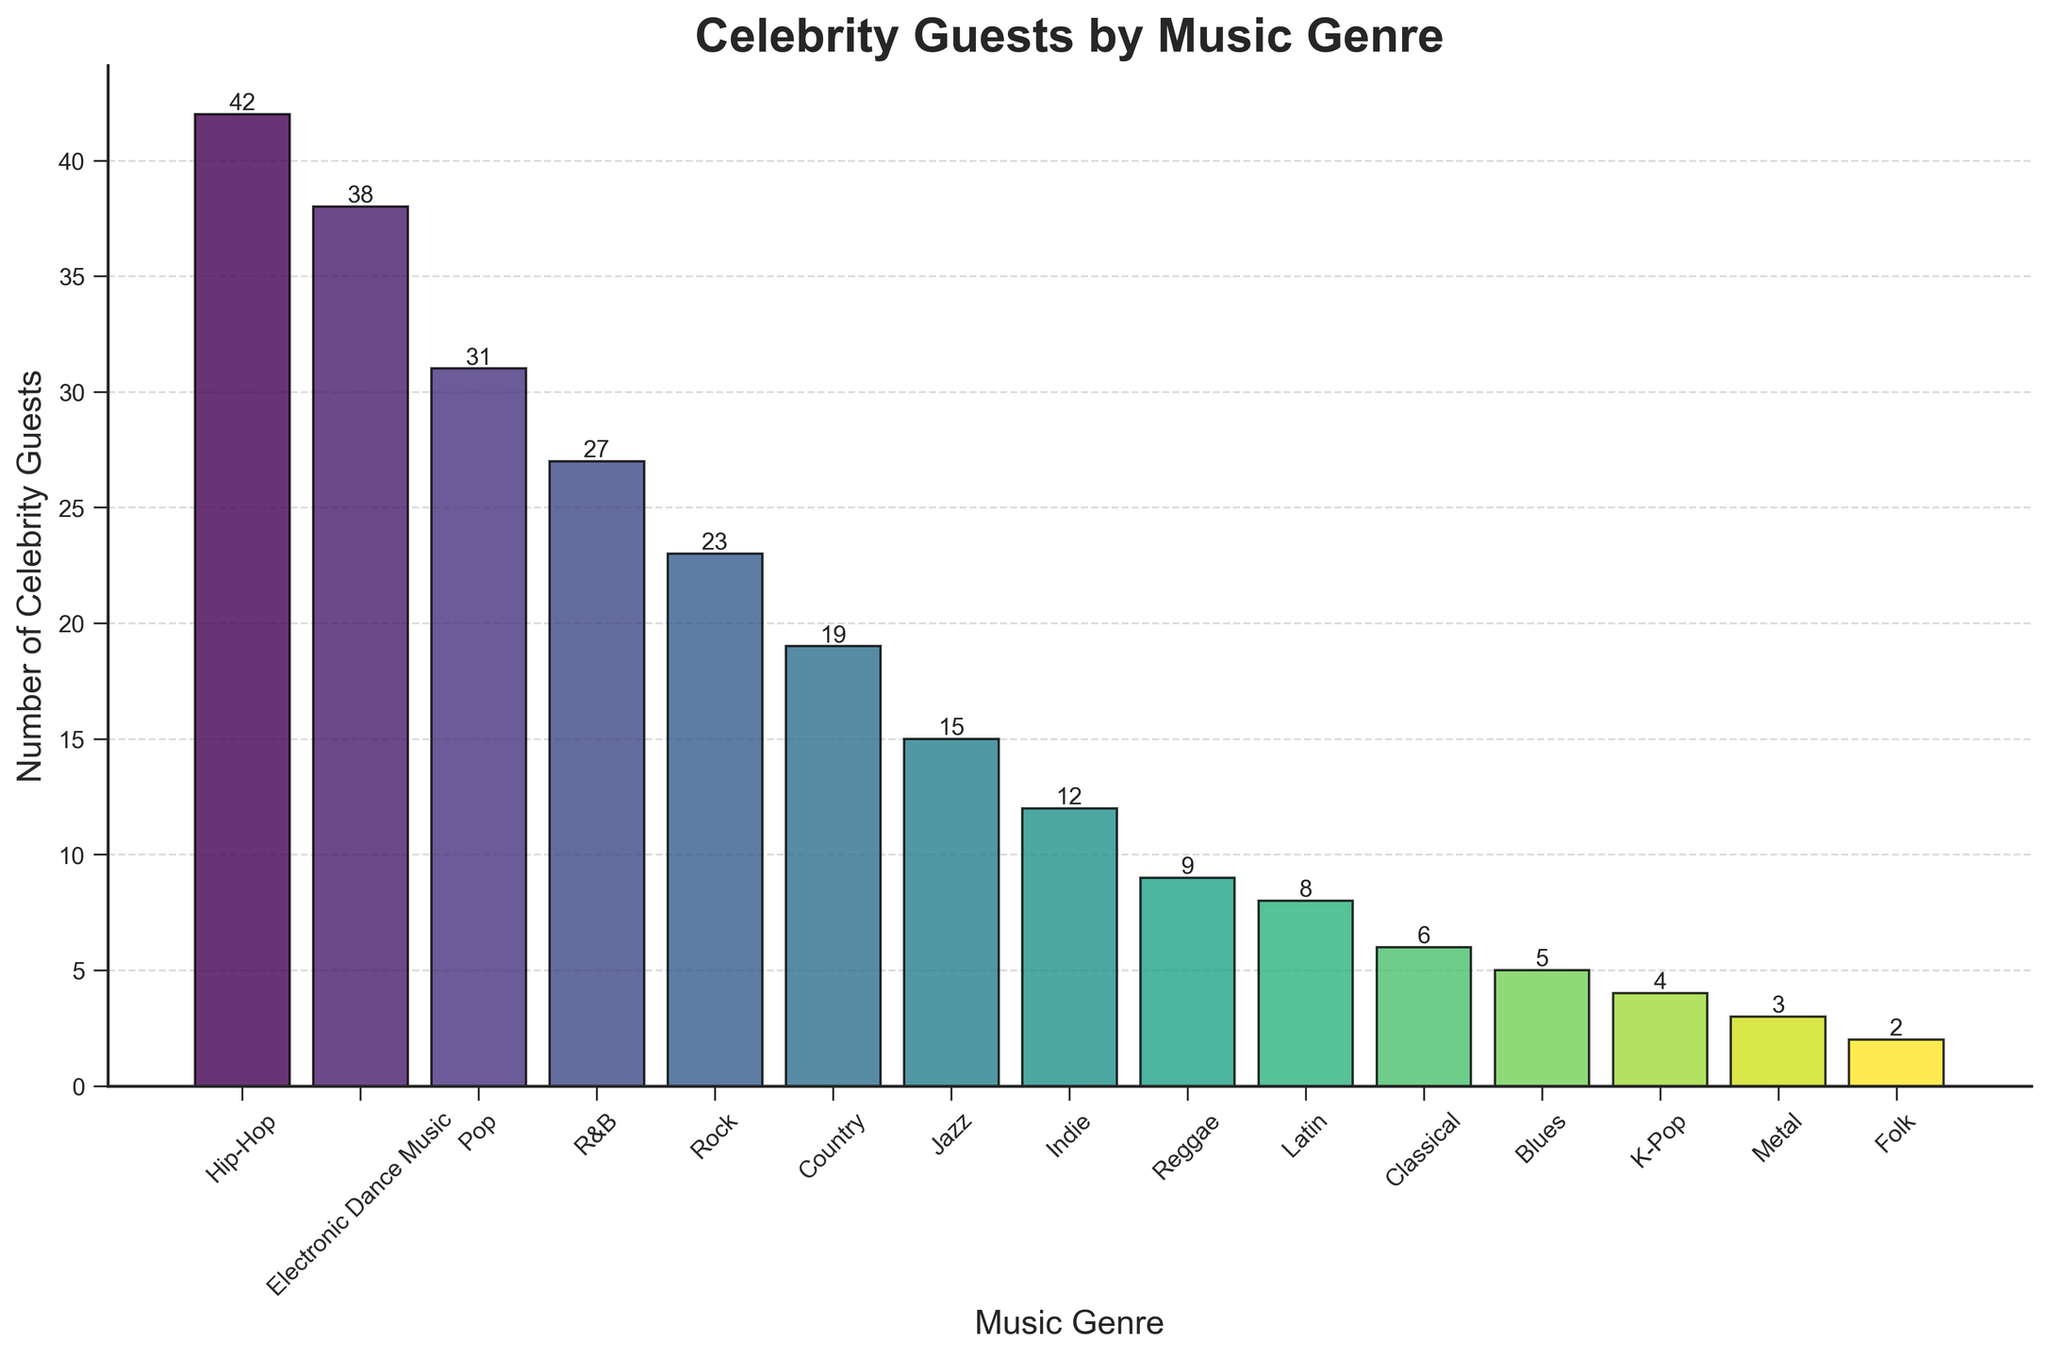How many more celebrity guests visited the bar for Hip-Hop compared to Latin music? To find how many more guests visited for Hip-Hop compared to Latin music, we need to subtract the number of celebrity guests for Latin (8) from the number for Hip-Hop (42). 42 - 8 = 34.
Answer: 34 Which music genre attracted the fewest celebrity guests? The genre with the fewest celebrity guests can be identified by finding the shortest bar. This is Metal, with only 3 guests.
Answer: Metal What is the sum of celebrity guests for Pop and Rock music genres? To find the sum of celebrity guests for Pop and Rock, add the number of guests for each genre. Pop has 31 guests and Rock has 23 guests. 31 + 23 = 54.
Answer: 54 How does the number of celebrity guests for Jazz compare to Country? To compare Jazz and Country, we look at the heights of their bars. Jazz has fewer guests (15) compared to Country (19).
Answer: Fewer Is there a music genre that has fewer than 10 celebrity guests? If so, which ones? We look at the bars with heights below 10 guests. The genres with fewer than 10 guests are Reggae (9), Latin (8), Classical (6), Blues (5), K-Pop (4), Metal (3), and Folk (2).
Answer: Reggae, Latin, Classical, Blues, K-Pop, Metal, Folk What is the total number of celebrity guests for all the genres with more than 20 guests? We sum the number of guests for Hip-Hop (42), Electronic Dance Music (38), Pop (31), and R&B (27) since these genres have more than 20 guests. 42 + 38 + 31 + 27 = 138.
Answer: 138 Which genre had the highest number of celebrity guests visiting the bar? The genre with the highest number of celebrity guests can be identified by finding the tallest bar. This is Hip-Hop, with 42 guests.
Answer: Hip-Hop What is the difference in the number of celebrity guests between the genres Jazz and Indie? To find the difference, we subtract the number of guests for Indie (12) from Jazz (15). 15 - 12 = 3.
Answer: 3 What is the average number of celebrity guests for the genres with fewer than 10 guests? To find the average, sum the guests for the genres with fewer than 10 guests (Reggae: 9, Latin: 8, Classical: 6, Blues: 5, K-Pop: 4, Metal: 3, Folk: 2) and divide by the number of those genres (7). (9 + 8 + 6 + 5 + 4 + 3 + 2) / 7 = 5.285714 ≈ 5.29.
Answer: 5.29 